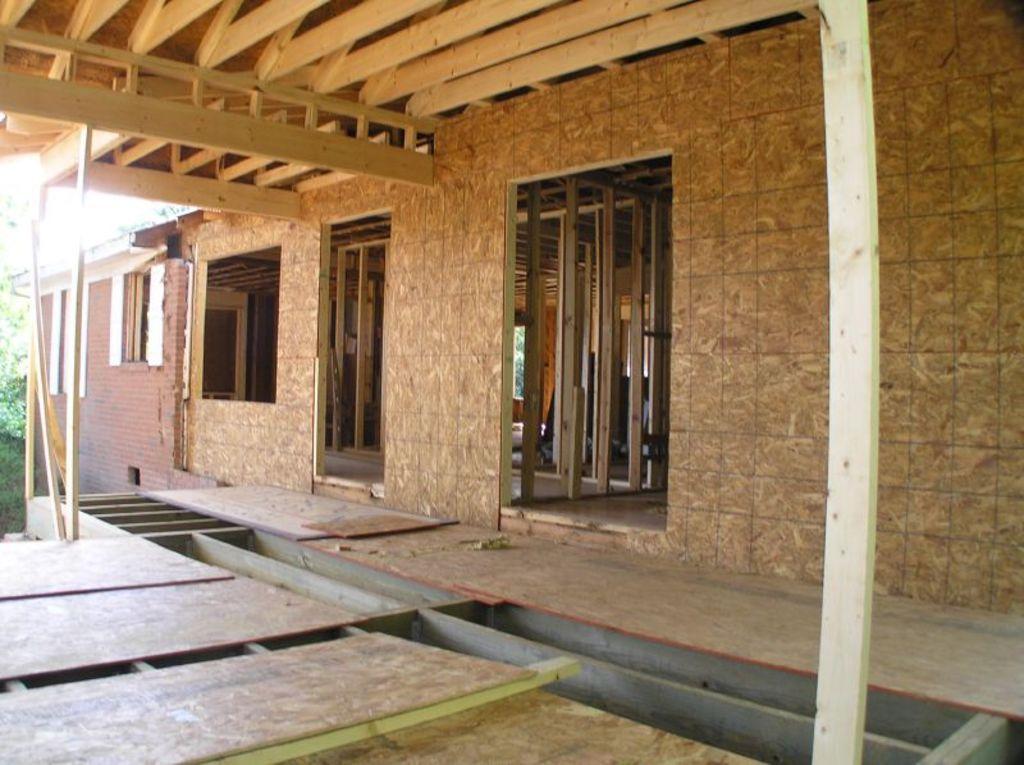Can you describe this image briefly? In this picture we can see a house, walls, wooden objects and in the background we can see leaves. 